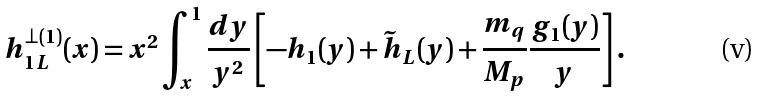<formula> <loc_0><loc_0><loc_500><loc_500>h _ { 1 L } ^ { \perp ( 1 ) } ( x ) = x ^ { 2 } \int _ { x } ^ { 1 } \frac { d y } { y ^ { 2 } } \left [ - h _ { 1 } ( y ) + \tilde { h } _ { L } ( y ) + \frac { m _ { q } } { M _ { p } } \frac { g _ { 1 } ( y ) } { y } \right ] .</formula> 